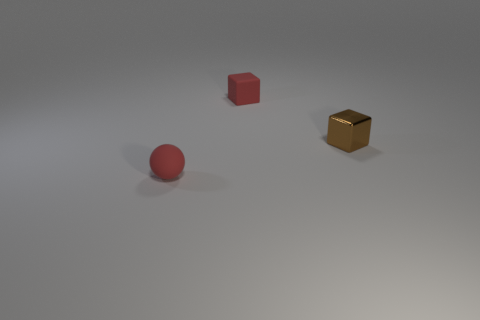If these objects were part of a larger scene, what could be their purpose? If we imagine these objects within a larger context, the red sphere could represent a playful element like a ball in a game, while the cubes might serve as structural components, such as building blocks in a child's toy set. How can we interpret their arrangement in relation to each other? The arrangement of these objects seems intentional, suggesting a sense of order or a moment frozen in time, like a still life composition in art. Their positioning invites the viewer to consider spatial relationships and the balance of forms in three-dimensional space. 